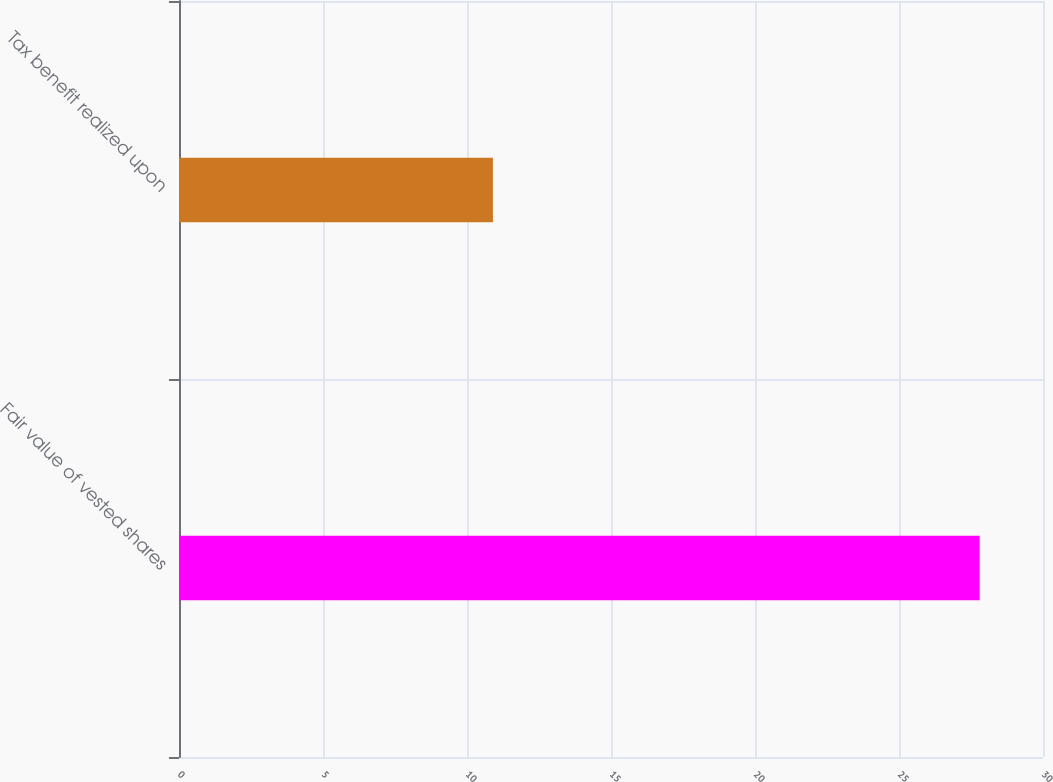Convert chart to OTSL. <chart><loc_0><loc_0><loc_500><loc_500><bar_chart><fcel>Fair value of vested shares<fcel>Tax benefit realized upon<nl><fcel>27.8<fcel>10.9<nl></chart> 